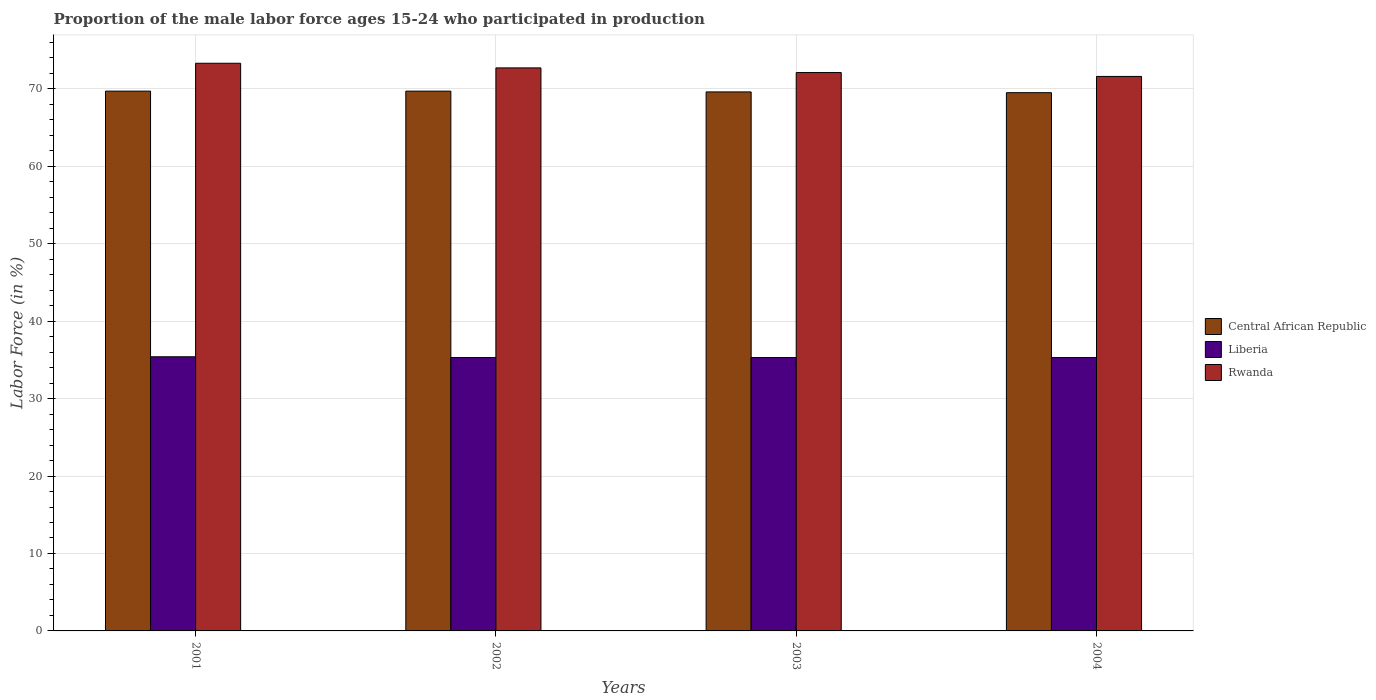How many different coloured bars are there?
Ensure brevity in your answer.  3. Are the number of bars per tick equal to the number of legend labels?
Ensure brevity in your answer.  Yes. Are the number of bars on each tick of the X-axis equal?
Offer a very short reply. Yes. How many bars are there on the 3rd tick from the left?
Make the answer very short. 3. How many bars are there on the 4th tick from the right?
Provide a succinct answer. 3. What is the label of the 2nd group of bars from the left?
Provide a succinct answer. 2002. In how many cases, is the number of bars for a given year not equal to the number of legend labels?
Your answer should be compact. 0. What is the proportion of the male labor force who participated in production in Liberia in 2004?
Offer a very short reply. 35.3. Across all years, what is the maximum proportion of the male labor force who participated in production in Central African Republic?
Give a very brief answer. 69.7. Across all years, what is the minimum proportion of the male labor force who participated in production in Central African Republic?
Give a very brief answer. 69.5. In which year was the proportion of the male labor force who participated in production in Liberia maximum?
Your answer should be compact. 2001. In which year was the proportion of the male labor force who participated in production in Liberia minimum?
Provide a short and direct response. 2002. What is the total proportion of the male labor force who participated in production in Rwanda in the graph?
Your answer should be compact. 289.7. What is the difference between the proportion of the male labor force who participated in production in Central African Republic in 2002 and that in 2004?
Offer a terse response. 0.2. What is the difference between the proportion of the male labor force who participated in production in Liberia in 2003 and the proportion of the male labor force who participated in production in Central African Republic in 2001?
Give a very brief answer. -34.4. What is the average proportion of the male labor force who participated in production in Central African Republic per year?
Provide a succinct answer. 69.62. In the year 2001, what is the difference between the proportion of the male labor force who participated in production in Liberia and proportion of the male labor force who participated in production in Rwanda?
Offer a terse response. -37.9. In how many years, is the proportion of the male labor force who participated in production in Central African Republic greater than 50 %?
Keep it short and to the point. 4. What is the ratio of the proportion of the male labor force who participated in production in Liberia in 2002 to that in 2003?
Give a very brief answer. 1. Is the proportion of the male labor force who participated in production in Liberia in 2001 less than that in 2004?
Your response must be concise. No. Is the difference between the proportion of the male labor force who participated in production in Liberia in 2003 and 2004 greater than the difference between the proportion of the male labor force who participated in production in Rwanda in 2003 and 2004?
Provide a succinct answer. No. What is the difference between the highest and the second highest proportion of the male labor force who participated in production in Rwanda?
Ensure brevity in your answer.  0.6. What is the difference between the highest and the lowest proportion of the male labor force who participated in production in Liberia?
Your response must be concise. 0.1. What does the 2nd bar from the left in 2004 represents?
Offer a very short reply. Liberia. What does the 1st bar from the right in 2002 represents?
Ensure brevity in your answer.  Rwanda. Is it the case that in every year, the sum of the proportion of the male labor force who participated in production in Rwanda and proportion of the male labor force who participated in production in Central African Republic is greater than the proportion of the male labor force who participated in production in Liberia?
Your response must be concise. Yes. How many bars are there?
Your answer should be very brief. 12. Are all the bars in the graph horizontal?
Make the answer very short. No. How many years are there in the graph?
Your response must be concise. 4. Does the graph contain any zero values?
Offer a terse response. No. Does the graph contain grids?
Ensure brevity in your answer.  Yes. Where does the legend appear in the graph?
Keep it short and to the point. Center right. How are the legend labels stacked?
Keep it short and to the point. Vertical. What is the title of the graph?
Provide a short and direct response. Proportion of the male labor force ages 15-24 who participated in production. What is the label or title of the X-axis?
Provide a succinct answer. Years. What is the Labor Force (in %) of Central African Republic in 2001?
Your answer should be very brief. 69.7. What is the Labor Force (in %) of Liberia in 2001?
Your response must be concise. 35.4. What is the Labor Force (in %) in Rwanda in 2001?
Offer a terse response. 73.3. What is the Labor Force (in %) in Central African Republic in 2002?
Your answer should be very brief. 69.7. What is the Labor Force (in %) of Liberia in 2002?
Offer a very short reply. 35.3. What is the Labor Force (in %) in Rwanda in 2002?
Ensure brevity in your answer.  72.7. What is the Labor Force (in %) of Central African Republic in 2003?
Keep it short and to the point. 69.6. What is the Labor Force (in %) of Liberia in 2003?
Your response must be concise. 35.3. What is the Labor Force (in %) in Rwanda in 2003?
Provide a short and direct response. 72.1. What is the Labor Force (in %) in Central African Republic in 2004?
Your answer should be very brief. 69.5. What is the Labor Force (in %) of Liberia in 2004?
Ensure brevity in your answer.  35.3. What is the Labor Force (in %) in Rwanda in 2004?
Your answer should be compact. 71.6. Across all years, what is the maximum Labor Force (in %) in Central African Republic?
Your response must be concise. 69.7. Across all years, what is the maximum Labor Force (in %) of Liberia?
Offer a terse response. 35.4. Across all years, what is the maximum Labor Force (in %) of Rwanda?
Keep it short and to the point. 73.3. Across all years, what is the minimum Labor Force (in %) in Central African Republic?
Your answer should be very brief. 69.5. Across all years, what is the minimum Labor Force (in %) in Liberia?
Keep it short and to the point. 35.3. Across all years, what is the minimum Labor Force (in %) of Rwanda?
Offer a terse response. 71.6. What is the total Labor Force (in %) in Central African Republic in the graph?
Give a very brief answer. 278.5. What is the total Labor Force (in %) of Liberia in the graph?
Offer a very short reply. 141.3. What is the total Labor Force (in %) of Rwanda in the graph?
Your answer should be very brief. 289.7. What is the difference between the Labor Force (in %) of Rwanda in 2001 and that in 2002?
Keep it short and to the point. 0.6. What is the difference between the Labor Force (in %) in Liberia in 2001 and that in 2003?
Keep it short and to the point. 0.1. What is the difference between the Labor Force (in %) of Rwanda in 2001 and that in 2003?
Ensure brevity in your answer.  1.2. What is the difference between the Labor Force (in %) of Rwanda in 2003 and that in 2004?
Your answer should be very brief. 0.5. What is the difference between the Labor Force (in %) in Central African Republic in 2001 and the Labor Force (in %) in Liberia in 2002?
Make the answer very short. 34.4. What is the difference between the Labor Force (in %) of Liberia in 2001 and the Labor Force (in %) of Rwanda in 2002?
Provide a succinct answer. -37.3. What is the difference between the Labor Force (in %) in Central African Republic in 2001 and the Labor Force (in %) in Liberia in 2003?
Your response must be concise. 34.4. What is the difference between the Labor Force (in %) of Liberia in 2001 and the Labor Force (in %) of Rwanda in 2003?
Your answer should be compact. -36.7. What is the difference between the Labor Force (in %) in Central African Republic in 2001 and the Labor Force (in %) in Liberia in 2004?
Provide a short and direct response. 34.4. What is the difference between the Labor Force (in %) of Liberia in 2001 and the Labor Force (in %) of Rwanda in 2004?
Your answer should be compact. -36.2. What is the difference between the Labor Force (in %) of Central African Republic in 2002 and the Labor Force (in %) of Liberia in 2003?
Your answer should be compact. 34.4. What is the difference between the Labor Force (in %) of Central African Republic in 2002 and the Labor Force (in %) of Rwanda in 2003?
Ensure brevity in your answer.  -2.4. What is the difference between the Labor Force (in %) of Liberia in 2002 and the Labor Force (in %) of Rwanda in 2003?
Give a very brief answer. -36.8. What is the difference between the Labor Force (in %) in Central African Republic in 2002 and the Labor Force (in %) in Liberia in 2004?
Provide a succinct answer. 34.4. What is the difference between the Labor Force (in %) in Central African Republic in 2002 and the Labor Force (in %) in Rwanda in 2004?
Your answer should be very brief. -1.9. What is the difference between the Labor Force (in %) in Liberia in 2002 and the Labor Force (in %) in Rwanda in 2004?
Provide a short and direct response. -36.3. What is the difference between the Labor Force (in %) of Central African Republic in 2003 and the Labor Force (in %) of Liberia in 2004?
Provide a short and direct response. 34.3. What is the difference between the Labor Force (in %) in Liberia in 2003 and the Labor Force (in %) in Rwanda in 2004?
Provide a short and direct response. -36.3. What is the average Labor Force (in %) of Central African Republic per year?
Your answer should be compact. 69.62. What is the average Labor Force (in %) in Liberia per year?
Offer a terse response. 35.33. What is the average Labor Force (in %) in Rwanda per year?
Provide a succinct answer. 72.42. In the year 2001, what is the difference between the Labor Force (in %) in Central African Republic and Labor Force (in %) in Liberia?
Offer a terse response. 34.3. In the year 2001, what is the difference between the Labor Force (in %) in Liberia and Labor Force (in %) in Rwanda?
Your answer should be compact. -37.9. In the year 2002, what is the difference between the Labor Force (in %) of Central African Republic and Labor Force (in %) of Liberia?
Keep it short and to the point. 34.4. In the year 2002, what is the difference between the Labor Force (in %) of Liberia and Labor Force (in %) of Rwanda?
Offer a very short reply. -37.4. In the year 2003, what is the difference between the Labor Force (in %) of Central African Republic and Labor Force (in %) of Liberia?
Give a very brief answer. 34.3. In the year 2003, what is the difference between the Labor Force (in %) of Liberia and Labor Force (in %) of Rwanda?
Your answer should be compact. -36.8. In the year 2004, what is the difference between the Labor Force (in %) in Central African Republic and Labor Force (in %) in Liberia?
Your answer should be very brief. 34.2. In the year 2004, what is the difference between the Labor Force (in %) in Liberia and Labor Force (in %) in Rwanda?
Keep it short and to the point. -36.3. What is the ratio of the Labor Force (in %) in Central African Republic in 2001 to that in 2002?
Make the answer very short. 1. What is the ratio of the Labor Force (in %) in Rwanda in 2001 to that in 2002?
Provide a short and direct response. 1.01. What is the ratio of the Labor Force (in %) of Liberia in 2001 to that in 2003?
Your answer should be compact. 1. What is the ratio of the Labor Force (in %) of Rwanda in 2001 to that in 2003?
Make the answer very short. 1.02. What is the ratio of the Labor Force (in %) in Central African Republic in 2001 to that in 2004?
Give a very brief answer. 1. What is the ratio of the Labor Force (in %) of Liberia in 2001 to that in 2004?
Your answer should be very brief. 1. What is the ratio of the Labor Force (in %) in Rwanda in 2001 to that in 2004?
Ensure brevity in your answer.  1.02. What is the ratio of the Labor Force (in %) of Central African Republic in 2002 to that in 2003?
Your response must be concise. 1. What is the ratio of the Labor Force (in %) of Rwanda in 2002 to that in 2003?
Offer a very short reply. 1.01. What is the ratio of the Labor Force (in %) in Rwanda in 2002 to that in 2004?
Your response must be concise. 1.02. What is the ratio of the Labor Force (in %) of Central African Republic in 2003 to that in 2004?
Your response must be concise. 1. What is the ratio of the Labor Force (in %) in Liberia in 2003 to that in 2004?
Provide a short and direct response. 1. What is the ratio of the Labor Force (in %) in Rwanda in 2003 to that in 2004?
Make the answer very short. 1.01. What is the difference between the highest and the second highest Labor Force (in %) in Central African Republic?
Your answer should be very brief. 0. What is the difference between the highest and the second highest Labor Force (in %) of Liberia?
Your answer should be compact. 0.1. What is the difference between the highest and the lowest Labor Force (in %) of Central African Republic?
Provide a short and direct response. 0.2. 